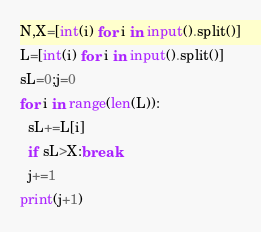Convert code to text. <code><loc_0><loc_0><loc_500><loc_500><_Python_>N,X=[int(i) for i in input().split()]
L=[int(i) for i in input().split()]
sL=0;j=0
for i in range(len(L)):
  sL+=L[i]
  if sL>X:break
  j+=1
print(j+1)</code> 